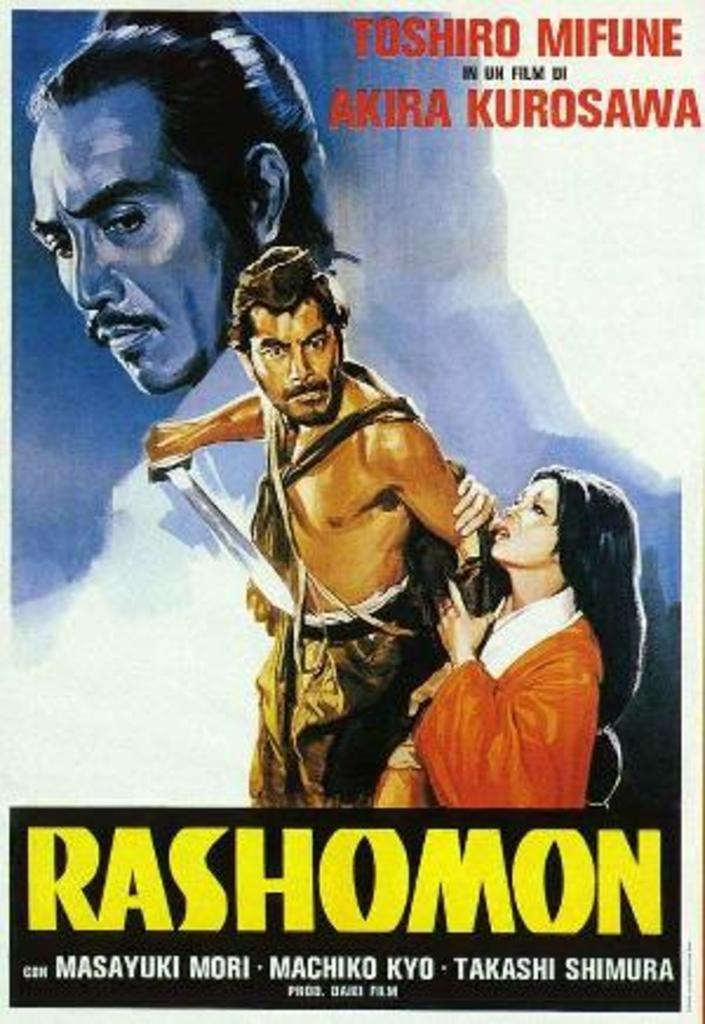Provide a one-sentence caption for the provided image. A book called Rashomon by Masayuki Mori, Machiko Kyo, and Takashi Shimura with people on the front cover. 